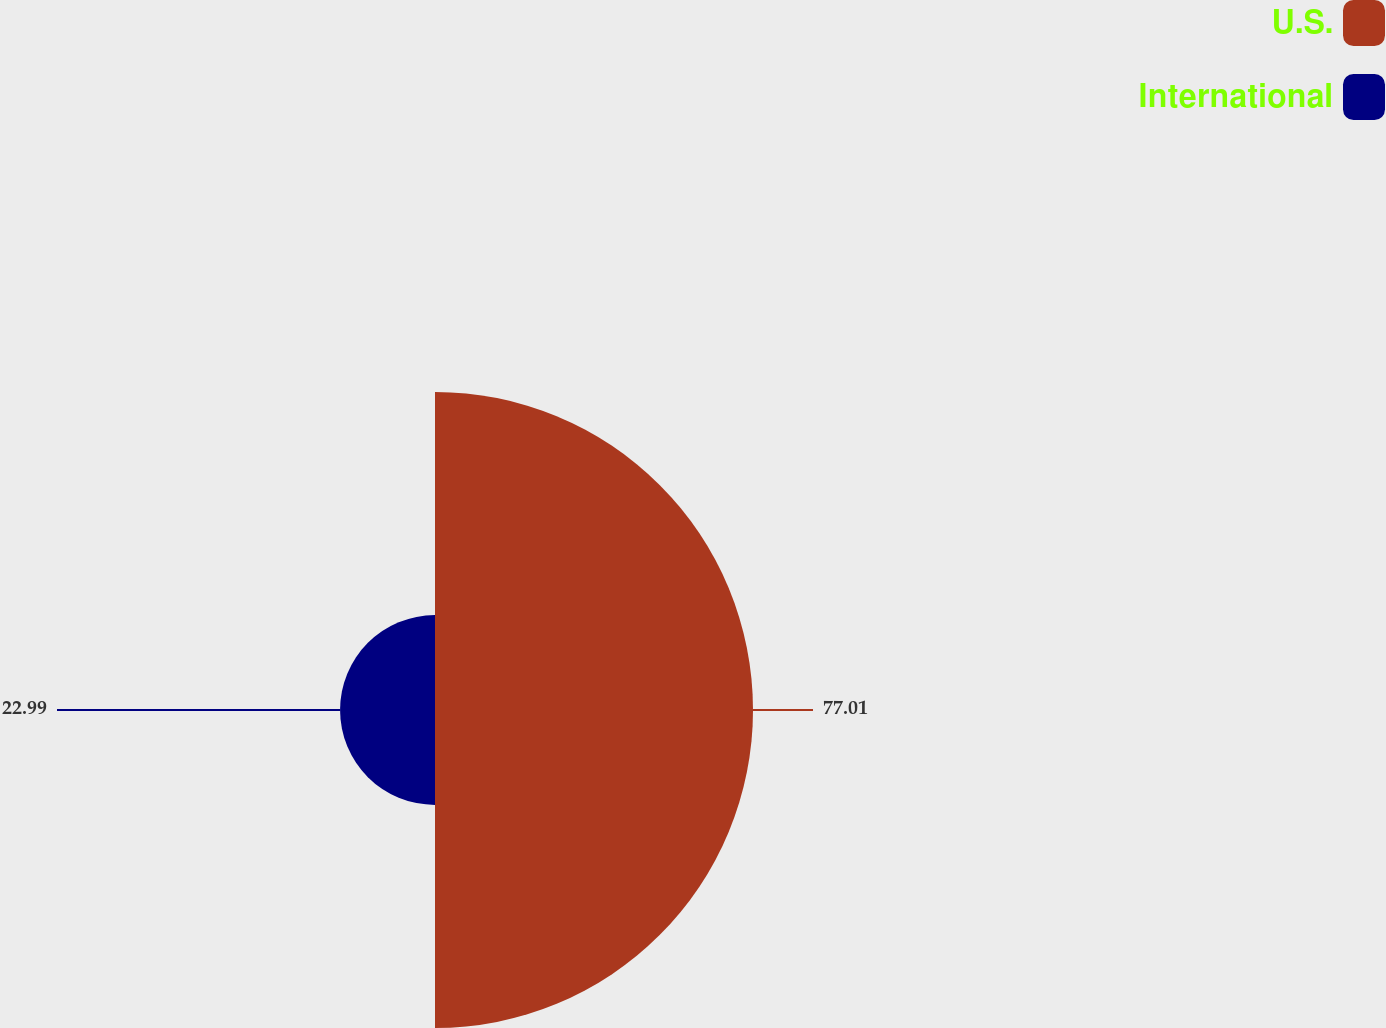Convert chart to OTSL. <chart><loc_0><loc_0><loc_500><loc_500><pie_chart><fcel>U.S.<fcel>International<nl><fcel>77.01%<fcel>22.99%<nl></chart> 